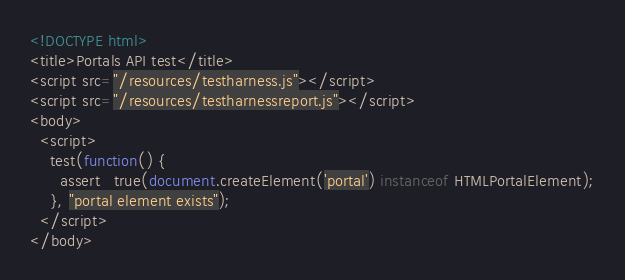<code> <loc_0><loc_0><loc_500><loc_500><_HTML_><!DOCTYPE html>
<title>Portals API test</title>
<script src="/resources/testharness.js"></script>
<script src="/resources/testharnessreport.js"></script>
<body>
  <script>
    test(function() {
      assert_true(document.createElement('portal') instanceof HTMLPortalElement);
    }, "portal element exists");
  </script>
</body>
</code> 